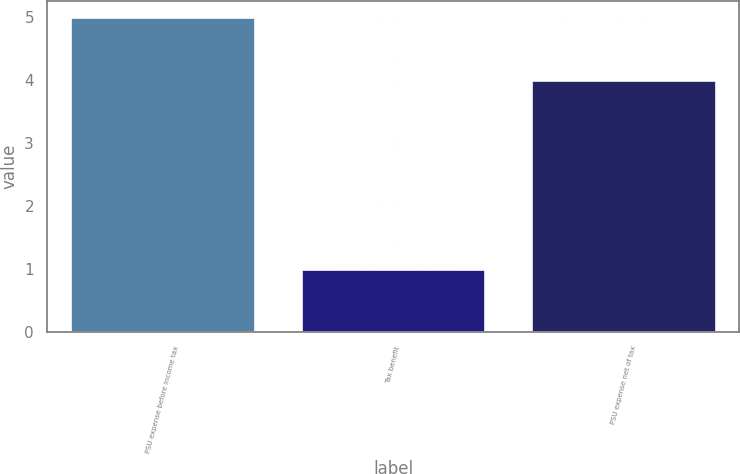Convert chart to OTSL. <chart><loc_0><loc_0><loc_500><loc_500><bar_chart><fcel>PSU expense before income tax<fcel>Tax benefit<fcel>PSU expense net of tax<nl><fcel>5<fcel>1<fcel>4<nl></chart> 